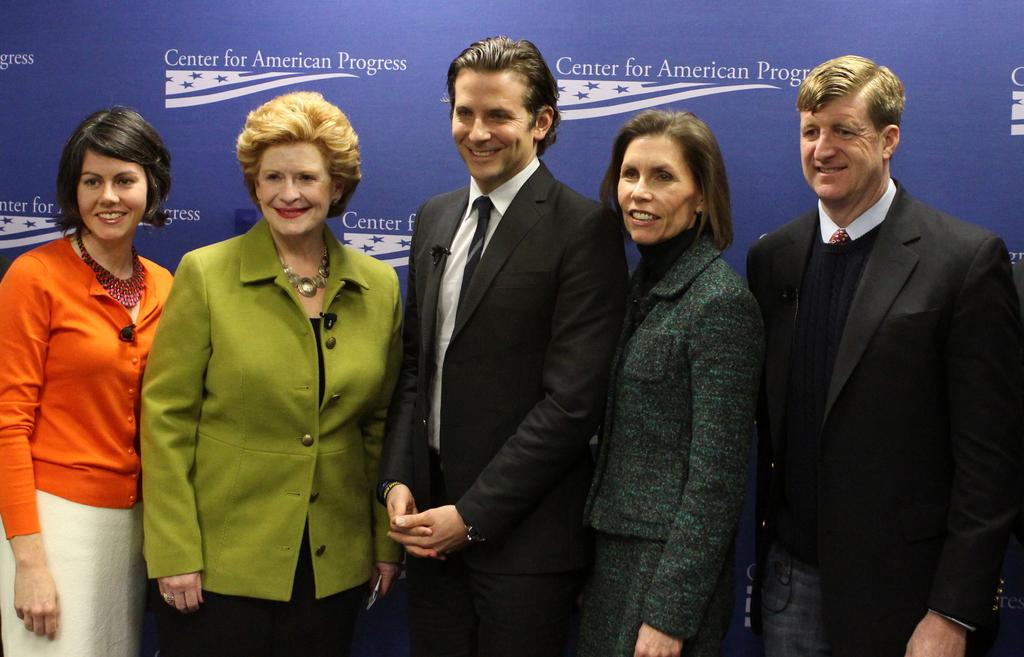How many people are in the foreground of the image? There are five people in the foreground of the image. What are the people in the image doing? The people are standing. What type of clothing are the people wearing? The people are wearing jackets and coats. What can be seen in the background of the image? There is a banner wall in the background of the image. What type of chess piece is on top of the stove in the image? There is no chess piece or stove present in the image. 